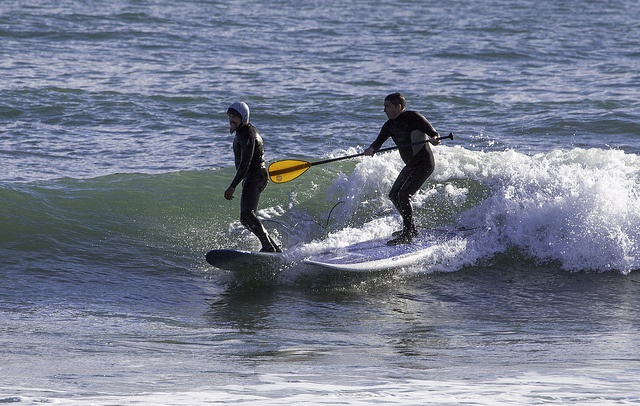Describe the objects in this image and their specific colors. I can see people in gray, black, and darkgray tones, surfboard in gray, darkgray, and lightgray tones, people in gray, black, navy, and darkgray tones, and surfboard in gray, black, and darkgray tones in this image. 